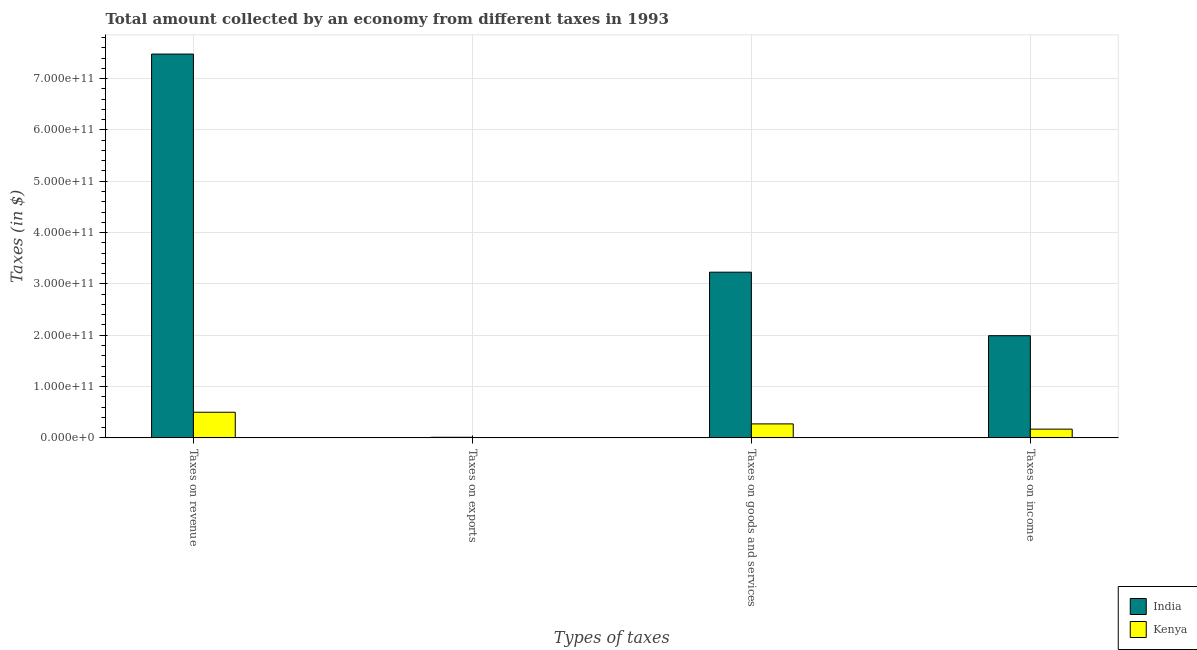How many different coloured bars are there?
Make the answer very short. 2. How many groups of bars are there?
Ensure brevity in your answer.  4. Are the number of bars per tick equal to the number of legend labels?
Your answer should be compact. Yes. Are the number of bars on each tick of the X-axis equal?
Ensure brevity in your answer.  Yes. How many bars are there on the 4th tick from the right?
Your answer should be compact. 2. What is the label of the 2nd group of bars from the left?
Keep it short and to the point. Taxes on exports. What is the amount collected as tax on exports in Kenya?
Ensure brevity in your answer.  1.00e+06. Across all countries, what is the maximum amount collected as tax on goods?
Offer a very short reply. 3.23e+11. Across all countries, what is the minimum amount collected as tax on goods?
Your response must be concise. 2.72e+1. In which country was the amount collected as tax on income minimum?
Give a very brief answer. Kenya. What is the total amount collected as tax on income in the graph?
Make the answer very short. 2.16e+11. What is the difference between the amount collected as tax on exports in Kenya and that in India?
Give a very brief answer. -1.15e+09. What is the difference between the amount collected as tax on revenue in India and the amount collected as tax on exports in Kenya?
Provide a short and direct response. 7.48e+11. What is the average amount collected as tax on revenue per country?
Keep it short and to the point. 3.99e+11. What is the difference between the amount collected as tax on goods and amount collected as tax on income in India?
Offer a terse response. 1.24e+11. In how many countries, is the amount collected as tax on goods greater than 120000000000 $?
Your answer should be compact. 1. What is the ratio of the amount collected as tax on exports in India to that in Kenya?
Provide a succinct answer. 1150. Is the difference between the amount collected as tax on exports in Kenya and India greater than the difference between the amount collected as tax on goods in Kenya and India?
Ensure brevity in your answer.  Yes. What is the difference between the highest and the second highest amount collected as tax on income?
Your response must be concise. 1.82e+11. What is the difference between the highest and the lowest amount collected as tax on exports?
Give a very brief answer. 1.15e+09. In how many countries, is the amount collected as tax on revenue greater than the average amount collected as tax on revenue taken over all countries?
Your answer should be compact. 1. Is it the case that in every country, the sum of the amount collected as tax on revenue and amount collected as tax on income is greater than the sum of amount collected as tax on exports and amount collected as tax on goods?
Make the answer very short. No. What does the 1st bar from the right in Taxes on income represents?
Ensure brevity in your answer.  Kenya. How many bars are there?
Offer a very short reply. 8. Are all the bars in the graph horizontal?
Offer a very short reply. No. What is the difference between two consecutive major ticks on the Y-axis?
Give a very brief answer. 1.00e+11. Where does the legend appear in the graph?
Provide a succinct answer. Bottom right. What is the title of the graph?
Offer a terse response. Total amount collected by an economy from different taxes in 1993. What is the label or title of the X-axis?
Make the answer very short. Types of taxes. What is the label or title of the Y-axis?
Your answer should be compact. Taxes (in $). What is the Taxes (in $) of India in Taxes on revenue?
Your response must be concise. 7.48e+11. What is the Taxes (in $) in Kenya in Taxes on revenue?
Your answer should be very brief. 4.99e+1. What is the Taxes (in $) in India in Taxes on exports?
Offer a very short reply. 1.15e+09. What is the Taxes (in $) of India in Taxes on goods and services?
Your answer should be very brief. 3.23e+11. What is the Taxes (in $) of Kenya in Taxes on goods and services?
Give a very brief answer. 2.72e+1. What is the Taxes (in $) in India in Taxes on income?
Your answer should be very brief. 1.99e+11. What is the Taxes (in $) in Kenya in Taxes on income?
Provide a succinct answer. 1.70e+1. Across all Types of taxes, what is the maximum Taxes (in $) in India?
Keep it short and to the point. 7.48e+11. Across all Types of taxes, what is the maximum Taxes (in $) of Kenya?
Keep it short and to the point. 4.99e+1. Across all Types of taxes, what is the minimum Taxes (in $) of India?
Your response must be concise. 1.15e+09. What is the total Taxes (in $) of India in the graph?
Give a very brief answer. 1.27e+12. What is the total Taxes (in $) of Kenya in the graph?
Give a very brief answer. 9.42e+1. What is the difference between the Taxes (in $) of India in Taxes on revenue and that in Taxes on exports?
Give a very brief answer. 7.47e+11. What is the difference between the Taxes (in $) of Kenya in Taxes on revenue and that in Taxes on exports?
Provide a succinct answer. 4.99e+1. What is the difference between the Taxes (in $) in India in Taxes on revenue and that in Taxes on goods and services?
Give a very brief answer. 4.25e+11. What is the difference between the Taxes (in $) in Kenya in Taxes on revenue and that in Taxes on goods and services?
Make the answer very short. 2.27e+1. What is the difference between the Taxes (in $) of India in Taxes on revenue and that in Taxes on income?
Give a very brief answer. 5.49e+11. What is the difference between the Taxes (in $) of Kenya in Taxes on revenue and that in Taxes on income?
Offer a terse response. 3.29e+1. What is the difference between the Taxes (in $) in India in Taxes on exports and that in Taxes on goods and services?
Provide a short and direct response. -3.22e+11. What is the difference between the Taxes (in $) in Kenya in Taxes on exports and that in Taxes on goods and services?
Your answer should be very brief. -2.72e+1. What is the difference between the Taxes (in $) in India in Taxes on exports and that in Taxes on income?
Offer a terse response. -1.98e+11. What is the difference between the Taxes (in $) in Kenya in Taxes on exports and that in Taxes on income?
Provide a short and direct response. -1.70e+1. What is the difference between the Taxes (in $) in India in Taxes on goods and services and that in Taxes on income?
Provide a short and direct response. 1.24e+11. What is the difference between the Taxes (in $) in Kenya in Taxes on goods and services and that in Taxes on income?
Offer a terse response. 1.02e+1. What is the difference between the Taxes (in $) in India in Taxes on revenue and the Taxes (in $) in Kenya in Taxes on exports?
Your answer should be very brief. 7.48e+11. What is the difference between the Taxes (in $) in India in Taxes on revenue and the Taxes (in $) in Kenya in Taxes on goods and services?
Provide a short and direct response. 7.20e+11. What is the difference between the Taxes (in $) in India in Taxes on revenue and the Taxes (in $) in Kenya in Taxes on income?
Offer a very short reply. 7.31e+11. What is the difference between the Taxes (in $) of India in Taxes on exports and the Taxes (in $) of Kenya in Taxes on goods and services?
Offer a terse response. -2.61e+1. What is the difference between the Taxes (in $) in India in Taxes on exports and the Taxes (in $) in Kenya in Taxes on income?
Provide a short and direct response. -1.59e+1. What is the difference between the Taxes (in $) of India in Taxes on goods and services and the Taxes (in $) of Kenya in Taxes on income?
Offer a terse response. 3.06e+11. What is the average Taxes (in $) in India per Types of taxes?
Your answer should be very brief. 3.18e+11. What is the average Taxes (in $) in Kenya per Types of taxes?
Make the answer very short. 2.35e+1. What is the difference between the Taxes (in $) in India and Taxes (in $) in Kenya in Taxes on revenue?
Your response must be concise. 6.98e+11. What is the difference between the Taxes (in $) in India and Taxes (in $) in Kenya in Taxes on exports?
Your response must be concise. 1.15e+09. What is the difference between the Taxes (in $) of India and Taxes (in $) of Kenya in Taxes on goods and services?
Your response must be concise. 2.96e+11. What is the difference between the Taxes (in $) of India and Taxes (in $) of Kenya in Taxes on income?
Provide a succinct answer. 1.82e+11. What is the ratio of the Taxes (in $) of India in Taxes on revenue to that in Taxes on exports?
Your answer should be compact. 650.16. What is the ratio of the Taxes (in $) in Kenya in Taxes on revenue to that in Taxes on exports?
Offer a terse response. 4.99e+04. What is the ratio of the Taxes (in $) of India in Taxes on revenue to that in Taxes on goods and services?
Offer a very short reply. 2.32. What is the ratio of the Taxes (in $) of Kenya in Taxes on revenue to that in Taxes on goods and services?
Keep it short and to the point. 1.83. What is the ratio of the Taxes (in $) in India in Taxes on revenue to that in Taxes on income?
Your answer should be very brief. 3.76. What is the ratio of the Taxes (in $) in Kenya in Taxes on revenue to that in Taxes on income?
Your answer should be very brief. 2.93. What is the ratio of the Taxes (in $) in India in Taxes on exports to that in Taxes on goods and services?
Provide a short and direct response. 0. What is the ratio of the Taxes (in $) of India in Taxes on exports to that in Taxes on income?
Your answer should be compact. 0.01. What is the ratio of the Taxes (in $) of India in Taxes on goods and services to that in Taxes on income?
Ensure brevity in your answer.  1.62. What is the ratio of the Taxes (in $) in Kenya in Taxes on goods and services to that in Taxes on income?
Your response must be concise. 1.6. What is the difference between the highest and the second highest Taxes (in $) in India?
Make the answer very short. 4.25e+11. What is the difference between the highest and the second highest Taxes (in $) in Kenya?
Provide a succinct answer. 2.27e+1. What is the difference between the highest and the lowest Taxes (in $) in India?
Offer a very short reply. 7.47e+11. What is the difference between the highest and the lowest Taxes (in $) in Kenya?
Offer a very short reply. 4.99e+1. 